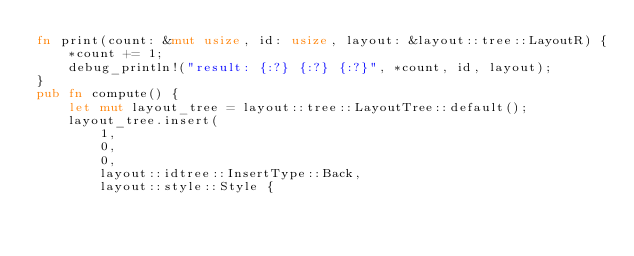Convert code to text. <code><loc_0><loc_0><loc_500><loc_500><_Rust_>fn print(count: &mut usize, id: usize, layout: &layout::tree::LayoutR) {
    *count += 1;
    debug_println!("result: {:?} {:?} {:?}", *count, id, layout);
}
pub fn compute() {
    let mut layout_tree = layout::tree::LayoutTree::default();
    layout_tree.insert(
        1,
        0,
        0,
        layout::idtree::InsertType::Back,
        layout::style::Style {</code> 